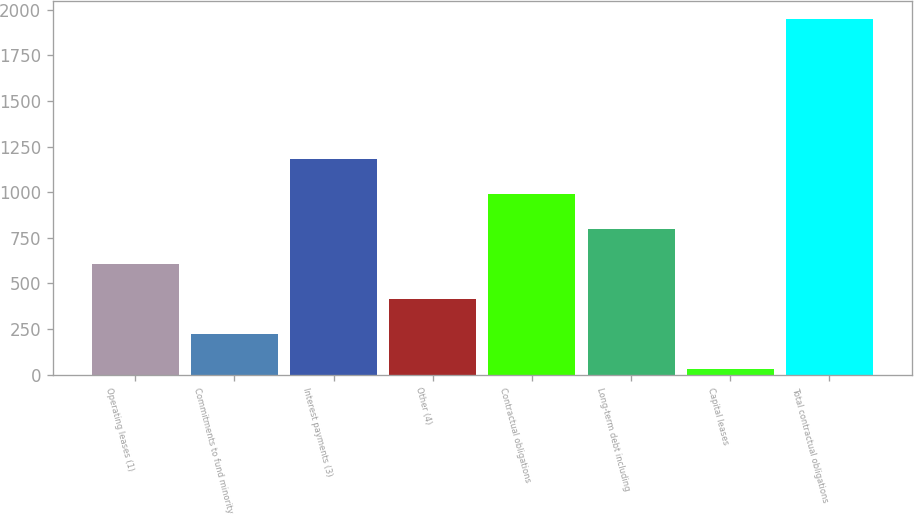Convert chart to OTSL. <chart><loc_0><loc_0><loc_500><loc_500><bar_chart><fcel>Operating leases (1)<fcel>Commitments to fund minority<fcel>Interest payments (3)<fcel>Other (4)<fcel>Contractual obligations<fcel>Long-term debt including<fcel>Capital leases<fcel>Total contractual obligations<nl><fcel>607.1<fcel>223.7<fcel>1182.2<fcel>415.4<fcel>990.5<fcel>798.8<fcel>32<fcel>1949<nl></chart> 